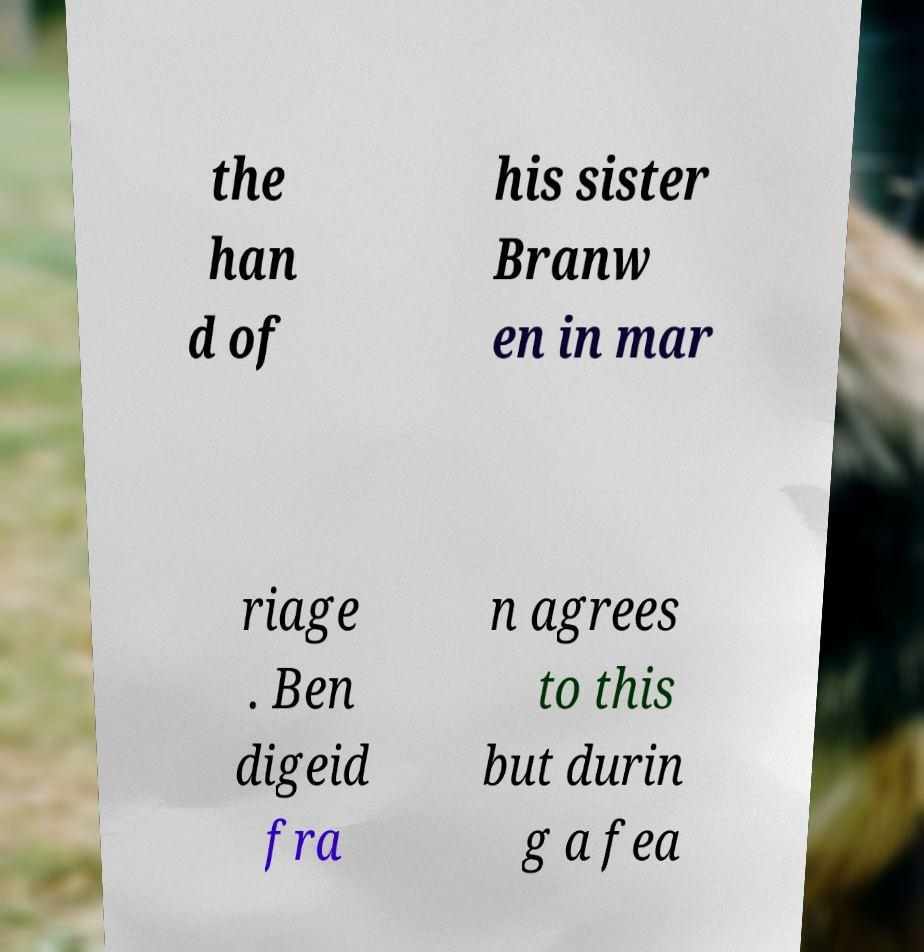I need the written content from this picture converted into text. Can you do that? the han d of his sister Branw en in mar riage . Ben digeid fra n agrees to this but durin g a fea 